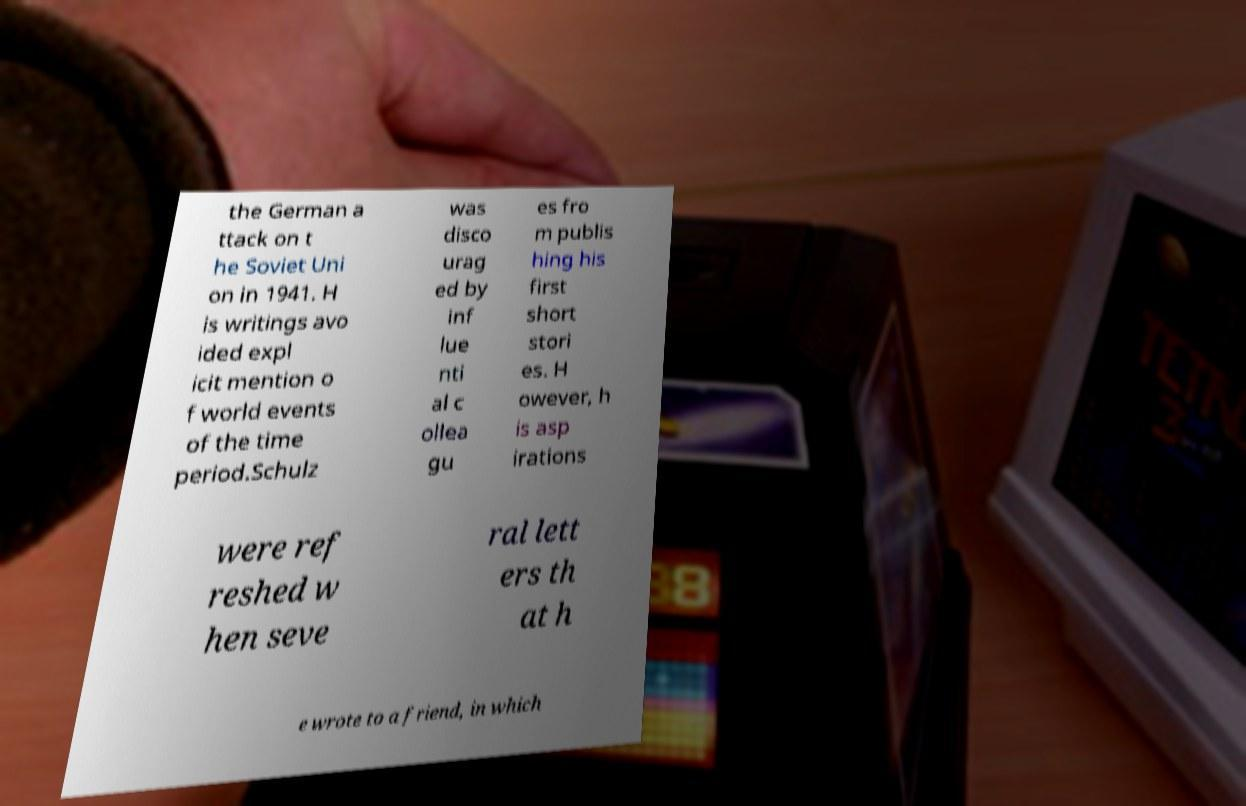For documentation purposes, I need the text within this image transcribed. Could you provide that? the German a ttack on t he Soviet Uni on in 1941. H is writings avo ided expl icit mention o f world events of the time period.Schulz was disco urag ed by inf lue nti al c ollea gu es fro m publis hing his first short stori es. H owever, h is asp irations were ref reshed w hen seve ral lett ers th at h e wrote to a friend, in which 